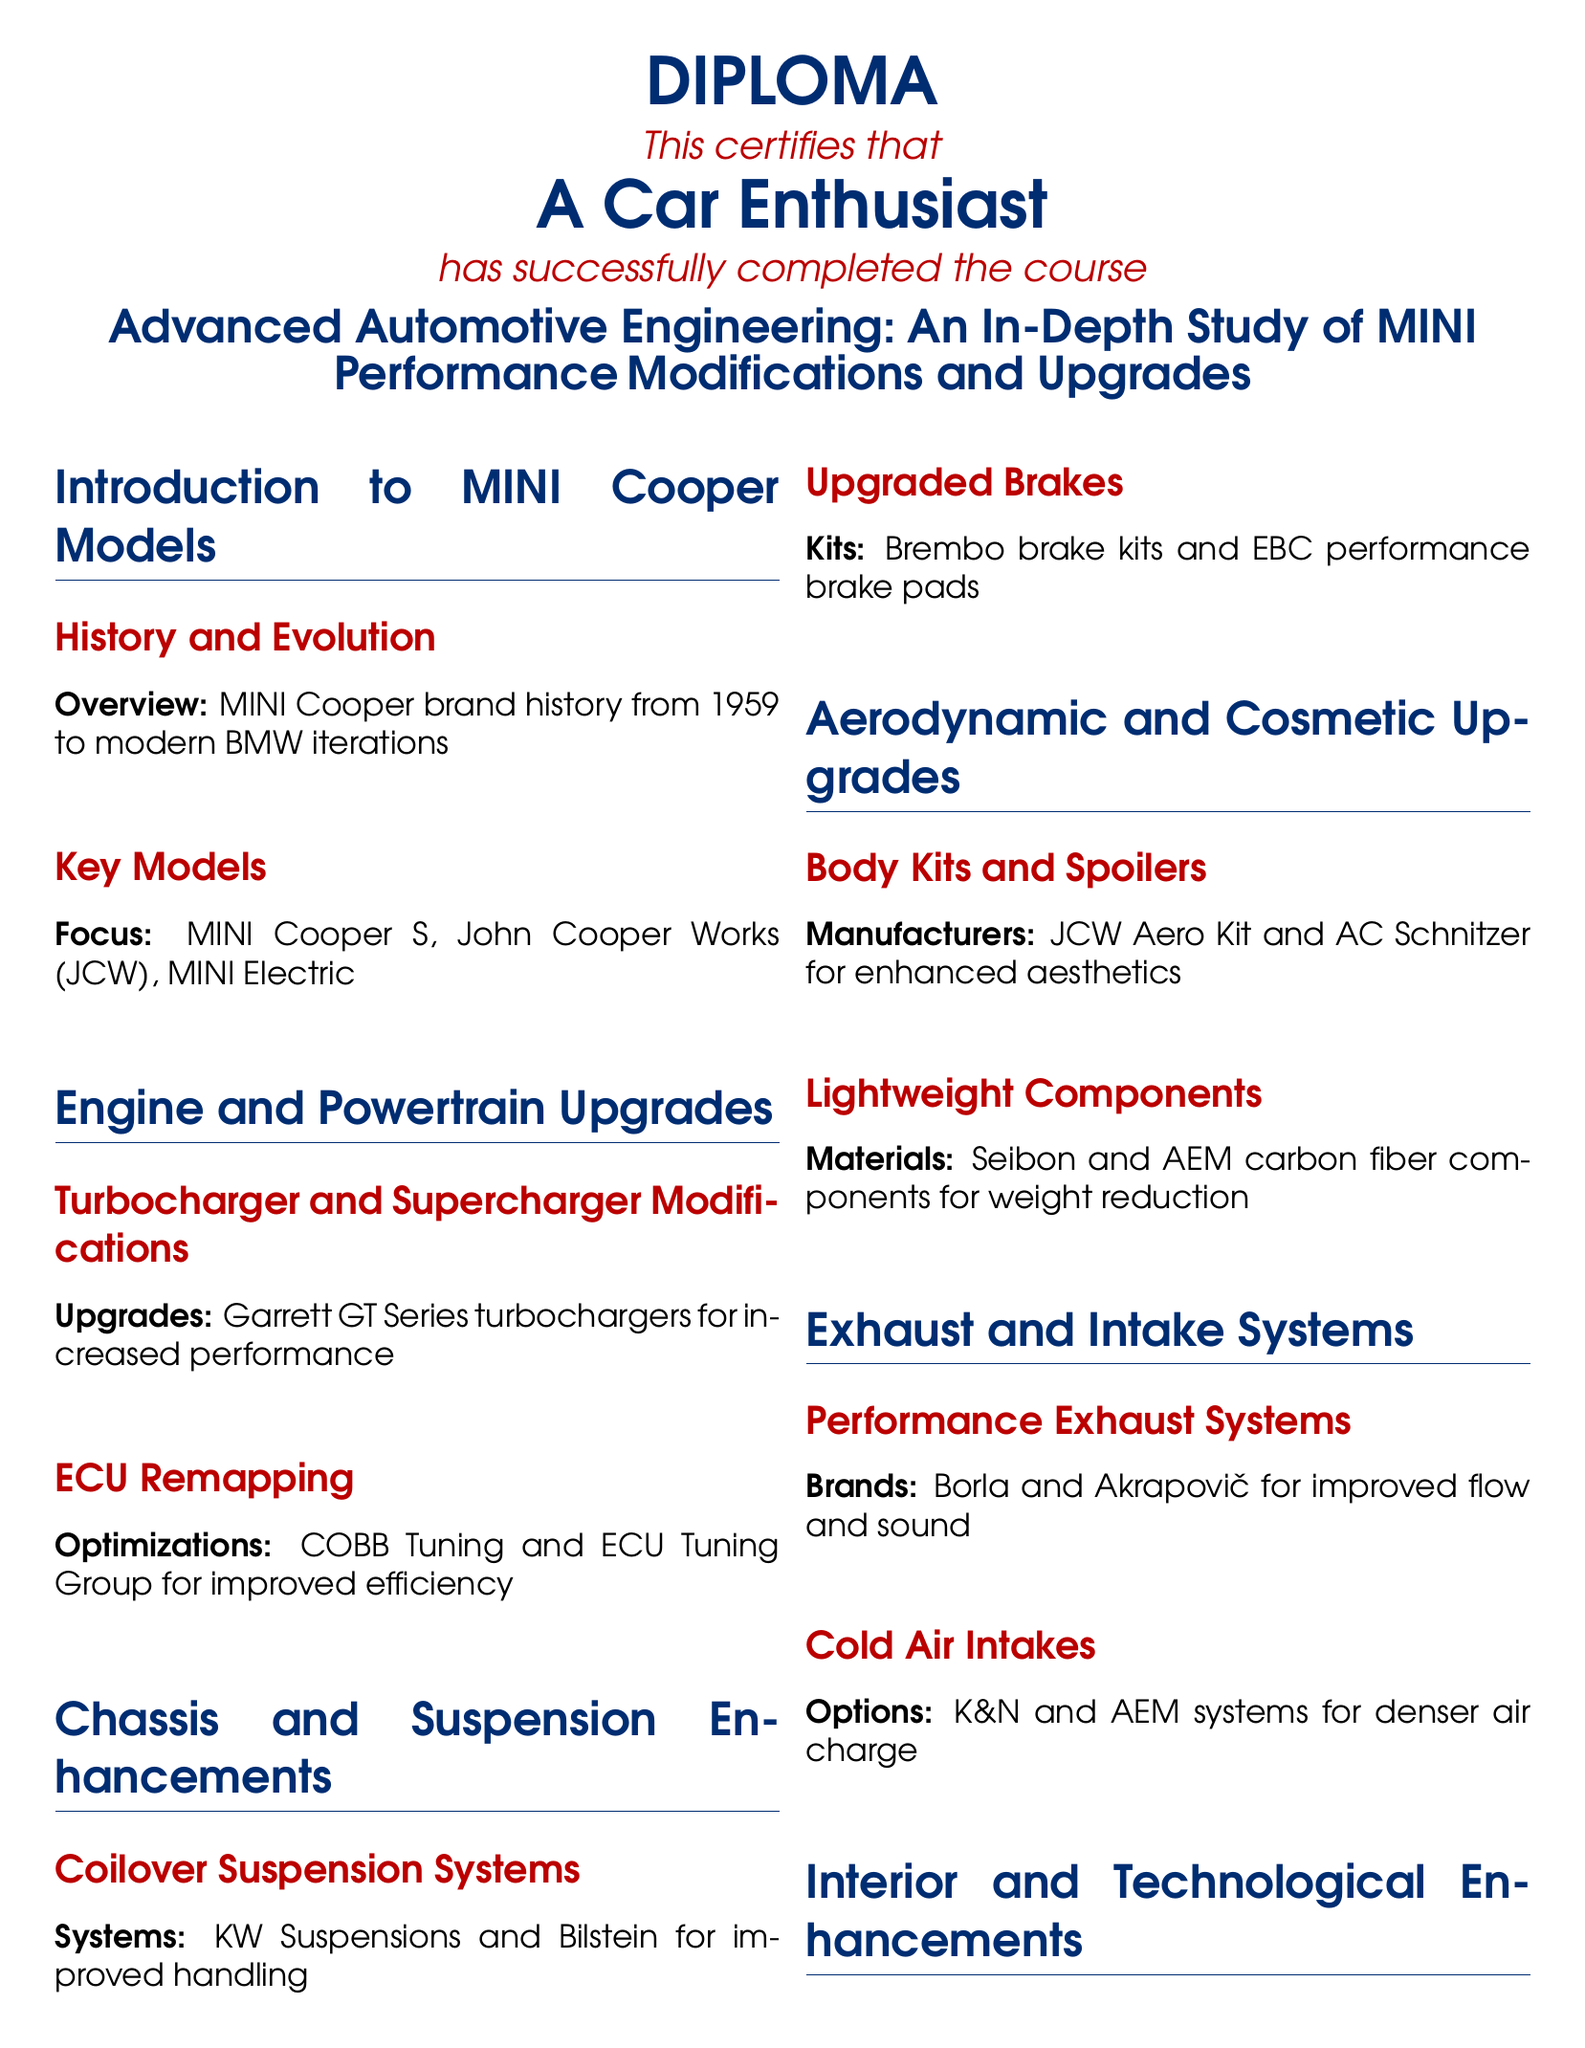What is the title of the diploma? The title is presented at the top of the document and includes the course name and focus area.
Answer: Advanced Automotive Engineering: An In-Depth Study of MINI Performance Modifications and Upgrades Who is certified by this diploma? The name is mentioned directly in the document as the person who completed the course.
Answer: A Car Enthusiast What year did the MINI Cooper brand start? The document states the beginning of the brand's history as 1959.
Answer: 1959 What type of turbochargers are mentioned for upgrades? The document specifies a certain type of turbocharger suitable for performance enhancements.
Answer: Garrett GT Series Name one brand of performance exhaust systems mentioned. The document lists various brands of performance exhaust systems for upgrades.
Answer: Borla What is one feature of coilover suspension systems listed? It describes the purpose or benefit of the mentioned suspension systems.
Answer: Improved handling Which company is listed for custom seat upgrades? The document names specific manufacturers known for their upgrades in comfort and support.
Answer: Recaro What system type is highlighted for advanced infotainment upgrades? The document outlines specific technological enhancements for MINI vehicles.
Answer: GPS and smartphone integration What type of brake kits does the document mention? The focus is on specific brands known for performance upgrades in braking systems.
Answer: Brembo brake kits 